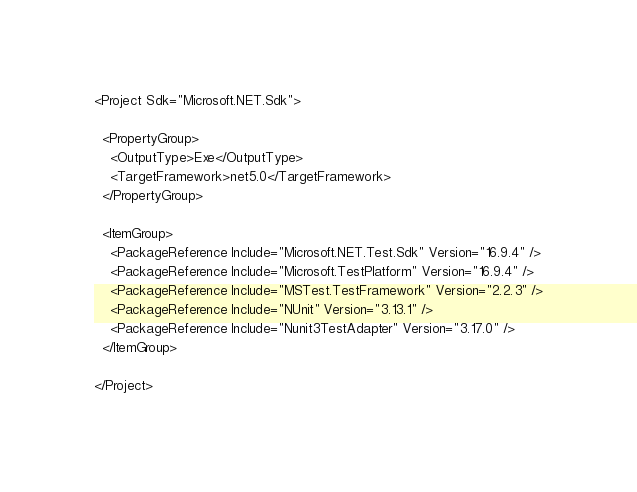<code> <loc_0><loc_0><loc_500><loc_500><_XML_><Project Sdk="Microsoft.NET.Sdk">

  <PropertyGroup>
    <OutputType>Exe</OutputType>
    <TargetFramework>net5.0</TargetFramework>
  </PropertyGroup>

  <ItemGroup>
    <PackageReference Include="Microsoft.NET.Test.Sdk" Version="16.9.4" />
    <PackageReference Include="Microsoft.TestPlatform" Version="16.9.4" />
    <PackageReference Include="MSTest.TestFramework" Version="2.2.3" />
    <PackageReference Include="NUnit" Version="3.13.1" />
    <PackageReference Include="Nunit3TestAdapter" Version="3.17.0" />
  </ItemGroup>

</Project>
</code> 